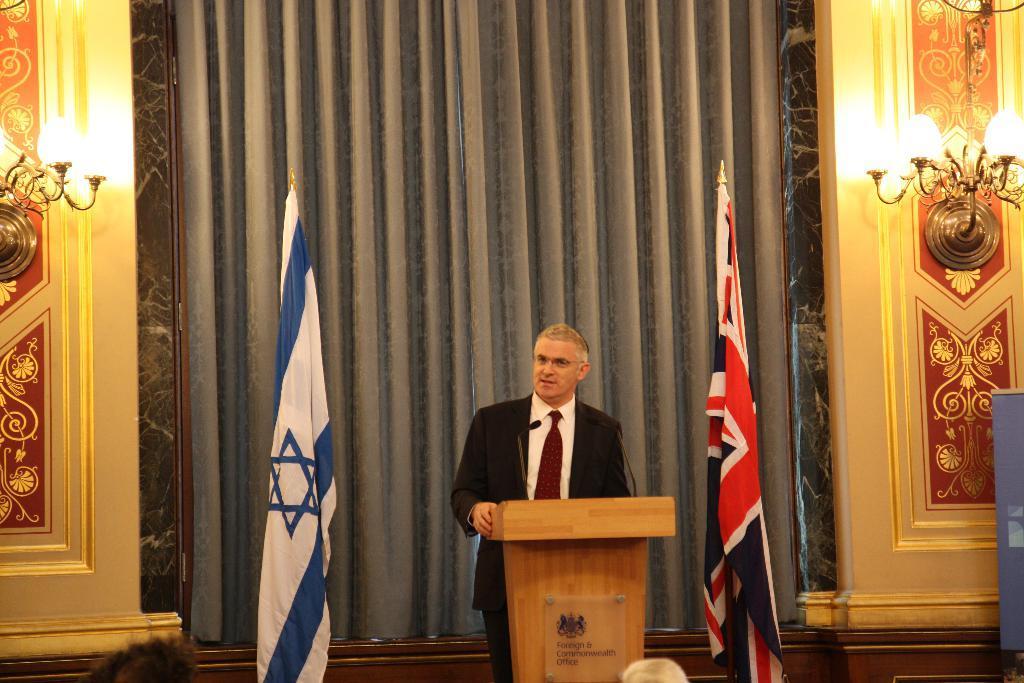Please provide a concise description of this image. In this image we can see a person standing. In front of him there is a podium. On that there is a board with something written. On the podium there are mics. In the back there are flags. In the background there is a wall with lights and some designs. 